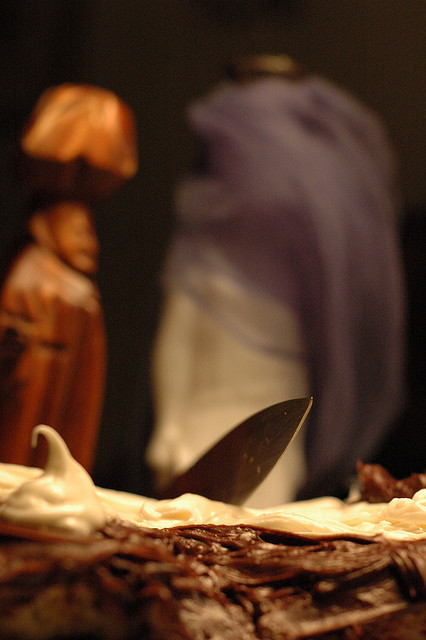<image>What is the object on the left? I am not sure what the object on the left is, it could be a wooden statue, cake, spoon, statue, lamp or bottle. What is the object on the left? I am not sure what the object on the left is. It can be a wooden statue, a wood sculpture, a cake, a spoon, a statue, a lamp, or a bottle. 